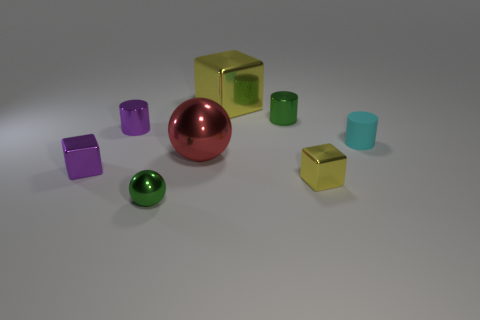There is a tiny green shiny thing behind the small yellow metallic thing; what shape is it?
Ensure brevity in your answer.  Cylinder. There is a small cyan thing that is behind the yellow object that is in front of the tiny cylinder on the left side of the tiny green ball; what is it made of?
Give a very brief answer. Rubber. What number of other things are the same size as the green cylinder?
Provide a succinct answer. 5. The small matte object is what color?
Your response must be concise. Cyan. There is a big object in front of the small shiny cylinder to the right of the tiny green shiny ball; what is its color?
Your answer should be compact. Red. There is a small metal ball; is it the same color as the metal cylinder right of the green ball?
Make the answer very short. Yes. There is a tiny green metallic object that is on the right side of the shiny ball in front of the purple cube; what number of purple cylinders are right of it?
Ensure brevity in your answer.  0. There is a large shiny ball; are there any green cylinders to the left of it?
Offer a very short reply. No. Is there any other thing that has the same color as the big cube?
Your response must be concise. Yes. What number of cylinders are small cyan rubber objects or big yellow things?
Make the answer very short. 1. 